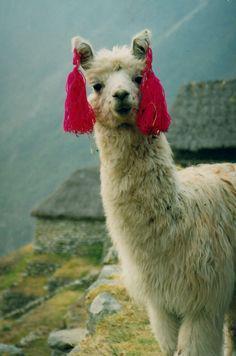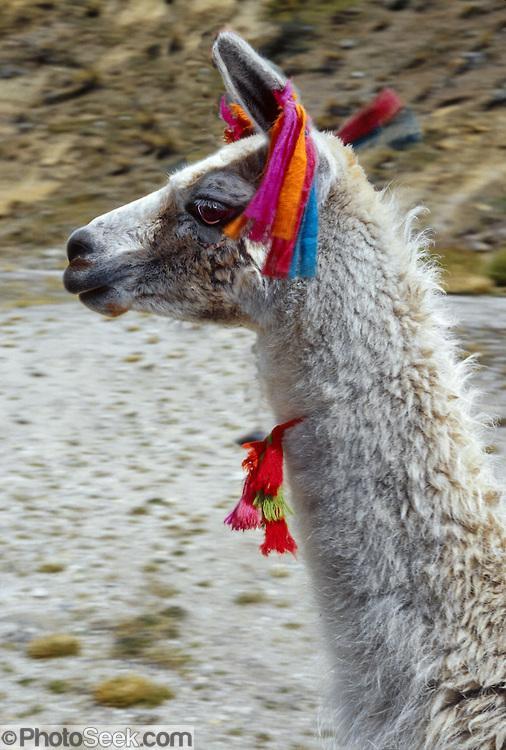The first image is the image on the left, the second image is the image on the right. Examine the images to the left and right. Is the description "Each image includes one foreground llama wearing a pair of colorful tassles somewhere on its head." accurate? Answer yes or no. Yes. The first image is the image on the left, the second image is the image on the right. Examine the images to the left and right. Is the description "Red material hangs from the ears of the animal in the image on the left." accurate? Answer yes or no. Yes. 